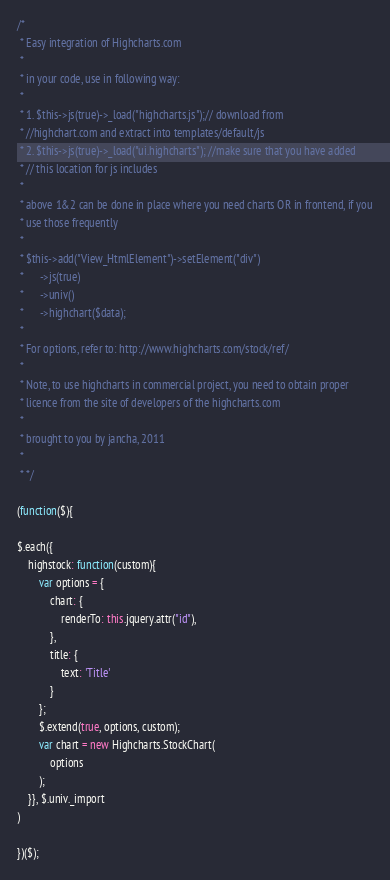<code> <loc_0><loc_0><loc_500><loc_500><_JavaScript_>/*
 * Easy integration of Highcharts.com
 *
 * in your code, use in following way:
 *
 * 1. $this->js(true)->_load("highcharts.js");// download from
 * //highchart.com and extract into templates/default/js
 * 2. $this->js(true)->_load("ui.highcharts"); //make sure that you have added
 * // this location for js includes
 *
 * above 1&2 can be done in place where you need charts OR in frontend, if you
 * use those frequently
 *
 * $this->add("View_HtmlElement")->setElement("div")
 *      ->js(true)
 *      ->univ()
 *      ->highchart($data);
 *
 * For options, refer to: http://www.highcharts.com/stock/ref/
 *
 * Note, to use highcharts in commercial project, you need to obtain proper
 * licence from the site of developers of the highcharts.com
 *
 * brought to you by jancha, 2011
 *
 * */

(function($){

$.each({
    highstock: function(custom){
        var options = {
            chart: {
                renderTo: this.jquery.attr("id"),
            },
            title: {
                text: 'Title'
            }
        };
        $.extend(true, options, custom);
        var chart = new Highcharts.StockChart(
            options
        );
    }}, $.univ._import
)
    
})($);
</code> 